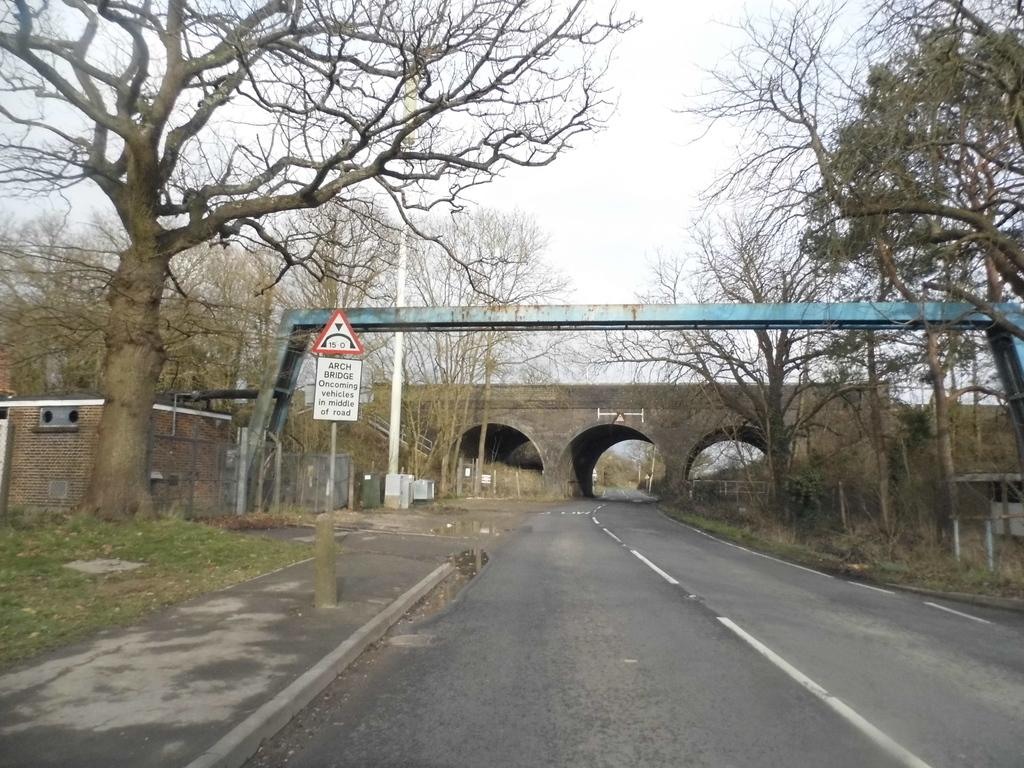What is the main feature of the image? The main feature of the image is an empty road. Are there any structures or objects present along the road? Yes, there is a bridge in the image. What type of vegetation can be seen beside the road? There are trees beside the road. What is attached to the pole in the image? There is a board on the pole in the image. What type of secretary can be seen working at the plot in the image? There is no secretary or plot present in the image. 